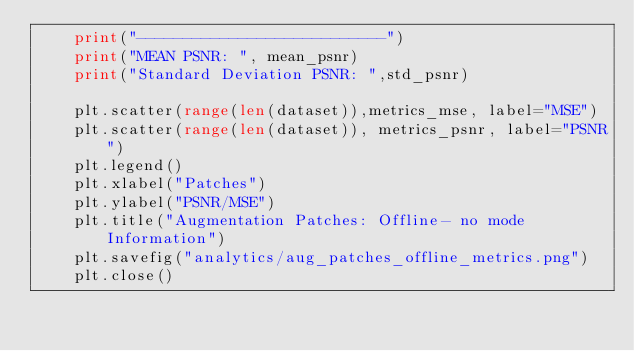Convert code to text. <code><loc_0><loc_0><loc_500><loc_500><_Python_>    print("---------------------------")
    print("MEAN PSNR: ", mean_psnr)
    print("Standard Deviation PSNR: ",std_psnr)

    plt.scatter(range(len(dataset)),metrics_mse, label="MSE")
    plt.scatter(range(len(dataset)), metrics_psnr, label="PSNR")
    plt.legend()
    plt.xlabel("Patches")
    plt.ylabel("PSNR/MSE")
    plt.title("Augmentation Patches: Offline- no mode Information")
    plt.savefig("analytics/aug_patches_offline_metrics.png")
    plt.close()







</code> 